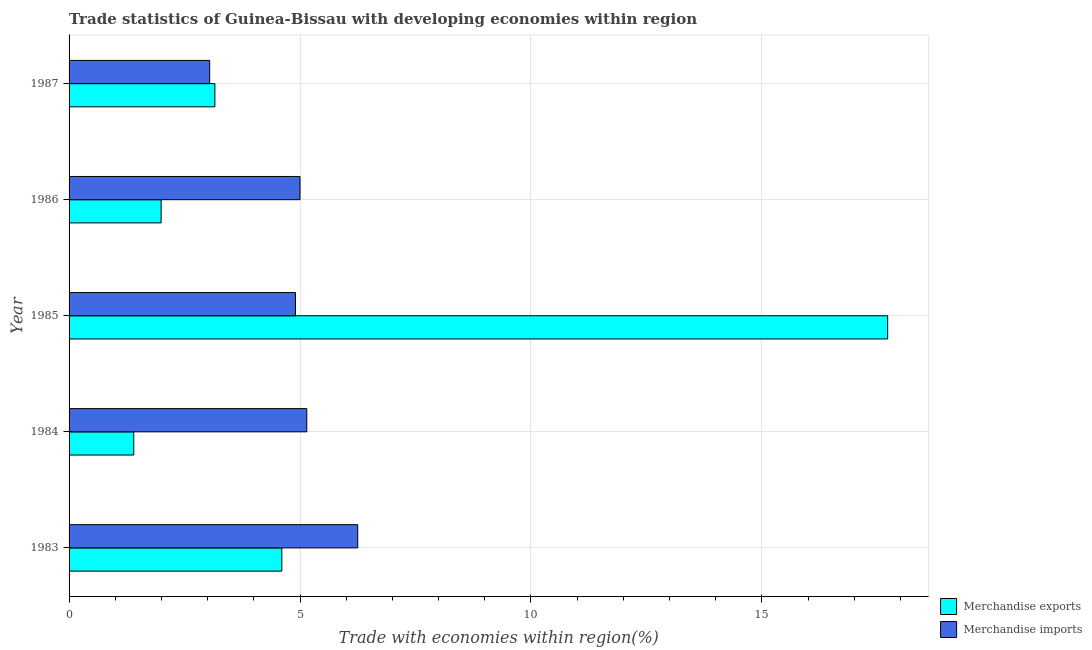How many different coloured bars are there?
Make the answer very short. 2. Are the number of bars on each tick of the Y-axis equal?
Your response must be concise. Yes. How many bars are there on the 3rd tick from the bottom?
Keep it short and to the point. 2. What is the label of the 4th group of bars from the top?
Make the answer very short. 1984. In how many cases, is the number of bars for a given year not equal to the number of legend labels?
Your response must be concise. 0. Across all years, what is the maximum merchandise imports?
Offer a very short reply. 6.25. Across all years, what is the minimum merchandise exports?
Ensure brevity in your answer.  1.4. What is the total merchandise imports in the graph?
Provide a succinct answer. 24.34. What is the difference between the merchandise imports in 1983 and that in 1986?
Your answer should be compact. 1.25. What is the difference between the merchandise exports in 1985 and the merchandise imports in 1986?
Provide a short and direct response. 12.72. What is the average merchandise imports per year?
Give a very brief answer. 4.87. In the year 1986, what is the difference between the merchandise imports and merchandise exports?
Your response must be concise. 3.01. What is the ratio of the merchandise exports in 1986 to that in 1987?
Your response must be concise. 0.63. Is the merchandise imports in 1984 less than that in 1987?
Your answer should be very brief. No. Is the difference between the merchandise exports in 1986 and 1987 greater than the difference between the merchandise imports in 1986 and 1987?
Your response must be concise. No. What is the difference between the highest and the second highest merchandise exports?
Ensure brevity in your answer.  13.12. What is the difference between the highest and the lowest merchandise exports?
Your answer should be compact. 16.32. In how many years, is the merchandise exports greater than the average merchandise exports taken over all years?
Your response must be concise. 1. Is the sum of the merchandise imports in 1983 and 1985 greater than the maximum merchandise exports across all years?
Provide a succinct answer. No. What does the 1st bar from the top in 1986 represents?
Offer a terse response. Merchandise imports. How many bars are there?
Ensure brevity in your answer.  10. What is the difference between two consecutive major ticks on the X-axis?
Give a very brief answer. 5. Are the values on the major ticks of X-axis written in scientific E-notation?
Your answer should be compact. No. Does the graph contain any zero values?
Keep it short and to the point. No. Does the graph contain grids?
Give a very brief answer. Yes. How are the legend labels stacked?
Ensure brevity in your answer.  Vertical. What is the title of the graph?
Keep it short and to the point. Trade statistics of Guinea-Bissau with developing economies within region. Does "Under-five" appear as one of the legend labels in the graph?
Your response must be concise. No. What is the label or title of the X-axis?
Offer a terse response. Trade with economies within region(%). What is the label or title of the Y-axis?
Keep it short and to the point. Year. What is the Trade with economies within region(%) of Merchandise exports in 1983?
Your answer should be very brief. 4.61. What is the Trade with economies within region(%) of Merchandise imports in 1983?
Keep it short and to the point. 6.25. What is the Trade with economies within region(%) in Merchandise exports in 1984?
Make the answer very short. 1.4. What is the Trade with economies within region(%) of Merchandise imports in 1984?
Offer a terse response. 5.15. What is the Trade with economies within region(%) in Merchandise exports in 1985?
Offer a very short reply. 17.72. What is the Trade with economies within region(%) of Merchandise imports in 1985?
Your response must be concise. 4.9. What is the Trade with economies within region(%) in Merchandise exports in 1986?
Give a very brief answer. 1.99. What is the Trade with economies within region(%) in Merchandise exports in 1987?
Your answer should be compact. 3.16. What is the Trade with economies within region(%) in Merchandise imports in 1987?
Ensure brevity in your answer.  3.04. Across all years, what is the maximum Trade with economies within region(%) in Merchandise exports?
Your answer should be compact. 17.72. Across all years, what is the maximum Trade with economies within region(%) of Merchandise imports?
Provide a short and direct response. 6.25. Across all years, what is the minimum Trade with economies within region(%) in Merchandise exports?
Your answer should be very brief. 1.4. Across all years, what is the minimum Trade with economies within region(%) in Merchandise imports?
Ensure brevity in your answer.  3.04. What is the total Trade with economies within region(%) in Merchandise exports in the graph?
Your answer should be compact. 28.88. What is the total Trade with economies within region(%) of Merchandise imports in the graph?
Your response must be concise. 24.34. What is the difference between the Trade with economies within region(%) of Merchandise exports in 1983 and that in 1984?
Keep it short and to the point. 3.21. What is the difference between the Trade with economies within region(%) of Merchandise imports in 1983 and that in 1984?
Provide a short and direct response. 1.1. What is the difference between the Trade with economies within region(%) in Merchandise exports in 1983 and that in 1985?
Your answer should be very brief. -13.12. What is the difference between the Trade with economies within region(%) in Merchandise imports in 1983 and that in 1985?
Make the answer very short. 1.35. What is the difference between the Trade with economies within region(%) in Merchandise exports in 1983 and that in 1986?
Your answer should be compact. 2.61. What is the difference between the Trade with economies within region(%) in Merchandise exports in 1983 and that in 1987?
Make the answer very short. 1.45. What is the difference between the Trade with economies within region(%) of Merchandise imports in 1983 and that in 1987?
Your answer should be very brief. 3.21. What is the difference between the Trade with economies within region(%) in Merchandise exports in 1984 and that in 1985?
Offer a terse response. -16.32. What is the difference between the Trade with economies within region(%) of Merchandise imports in 1984 and that in 1985?
Your answer should be compact. 0.25. What is the difference between the Trade with economies within region(%) in Merchandise exports in 1984 and that in 1986?
Offer a terse response. -0.59. What is the difference between the Trade with economies within region(%) in Merchandise imports in 1984 and that in 1986?
Your response must be concise. 0.15. What is the difference between the Trade with economies within region(%) of Merchandise exports in 1984 and that in 1987?
Your response must be concise. -1.76. What is the difference between the Trade with economies within region(%) in Merchandise imports in 1984 and that in 1987?
Keep it short and to the point. 2.1. What is the difference between the Trade with economies within region(%) of Merchandise exports in 1985 and that in 1986?
Your answer should be compact. 15.73. What is the difference between the Trade with economies within region(%) of Merchandise imports in 1985 and that in 1986?
Make the answer very short. -0.1. What is the difference between the Trade with economies within region(%) of Merchandise exports in 1985 and that in 1987?
Your response must be concise. 14.57. What is the difference between the Trade with economies within region(%) of Merchandise imports in 1985 and that in 1987?
Ensure brevity in your answer.  1.86. What is the difference between the Trade with economies within region(%) in Merchandise exports in 1986 and that in 1987?
Your answer should be compact. -1.16. What is the difference between the Trade with economies within region(%) in Merchandise imports in 1986 and that in 1987?
Offer a terse response. 1.96. What is the difference between the Trade with economies within region(%) of Merchandise exports in 1983 and the Trade with economies within region(%) of Merchandise imports in 1984?
Provide a succinct answer. -0.54. What is the difference between the Trade with economies within region(%) of Merchandise exports in 1983 and the Trade with economies within region(%) of Merchandise imports in 1985?
Your answer should be very brief. -0.3. What is the difference between the Trade with economies within region(%) in Merchandise exports in 1983 and the Trade with economies within region(%) in Merchandise imports in 1986?
Offer a terse response. -0.39. What is the difference between the Trade with economies within region(%) of Merchandise exports in 1983 and the Trade with economies within region(%) of Merchandise imports in 1987?
Provide a short and direct response. 1.56. What is the difference between the Trade with economies within region(%) in Merchandise exports in 1984 and the Trade with economies within region(%) in Merchandise imports in 1985?
Offer a terse response. -3.5. What is the difference between the Trade with economies within region(%) in Merchandise exports in 1984 and the Trade with economies within region(%) in Merchandise imports in 1986?
Offer a terse response. -3.6. What is the difference between the Trade with economies within region(%) of Merchandise exports in 1984 and the Trade with economies within region(%) of Merchandise imports in 1987?
Provide a succinct answer. -1.64. What is the difference between the Trade with economies within region(%) in Merchandise exports in 1985 and the Trade with economies within region(%) in Merchandise imports in 1986?
Your answer should be compact. 12.72. What is the difference between the Trade with economies within region(%) in Merchandise exports in 1985 and the Trade with economies within region(%) in Merchandise imports in 1987?
Give a very brief answer. 14.68. What is the difference between the Trade with economies within region(%) of Merchandise exports in 1986 and the Trade with economies within region(%) of Merchandise imports in 1987?
Ensure brevity in your answer.  -1.05. What is the average Trade with economies within region(%) of Merchandise exports per year?
Your answer should be compact. 5.78. What is the average Trade with economies within region(%) in Merchandise imports per year?
Ensure brevity in your answer.  4.87. In the year 1983, what is the difference between the Trade with economies within region(%) of Merchandise exports and Trade with economies within region(%) of Merchandise imports?
Keep it short and to the point. -1.64. In the year 1984, what is the difference between the Trade with economies within region(%) in Merchandise exports and Trade with economies within region(%) in Merchandise imports?
Your answer should be very brief. -3.75. In the year 1985, what is the difference between the Trade with economies within region(%) in Merchandise exports and Trade with economies within region(%) in Merchandise imports?
Keep it short and to the point. 12.82. In the year 1986, what is the difference between the Trade with economies within region(%) in Merchandise exports and Trade with economies within region(%) in Merchandise imports?
Your answer should be compact. -3.01. In the year 1987, what is the difference between the Trade with economies within region(%) of Merchandise exports and Trade with economies within region(%) of Merchandise imports?
Your response must be concise. 0.11. What is the ratio of the Trade with economies within region(%) in Merchandise exports in 1983 to that in 1984?
Keep it short and to the point. 3.29. What is the ratio of the Trade with economies within region(%) of Merchandise imports in 1983 to that in 1984?
Provide a short and direct response. 1.21. What is the ratio of the Trade with economies within region(%) in Merchandise exports in 1983 to that in 1985?
Your response must be concise. 0.26. What is the ratio of the Trade with economies within region(%) in Merchandise imports in 1983 to that in 1985?
Give a very brief answer. 1.27. What is the ratio of the Trade with economies within region(%) in Merchandise exports in 1983 to that in 1986?
Give a very brief answer. 2.31. What is the ratio of the Trade with economies within region(%) in Merchandise imports in 1983 to that in 1986?
Provide a succinct answer. 1.25. What is the ratio of the Trade with economies within region(%) in Merchandise exports in 1983 to that in 1987?
Offer a terse response. 1.46. What is the ratio of the Trade with economies within region(%) in Merchandise imports in 1983 to that in 1987?
Provide a short and direct response. 2.05. What is the ratio of the Trade with economies within region(%) of Merchandise exports in 1984 to that in 1985?
Make the answer very short. 0.08. What is the ratio of the Trade with economies within region(%) of Merchandise exports in 1984 to that in 1986?
Keep it short and to the point. 0.7. What is the ratio of the Trade with economies within region(%) in Merchandise imports in 1984 to that in 1986?
Provide a succinct answer. 1.03. What is the ratio of the Trade with economies within region(%) in Merchandise exports in 1984 to that in 1987?
Offer a very short reply. 0.44. What is the ratio of the Trade with economies within region(%) in Merchandise imports in 1984 to that in 1987?
Keep it short and to the point. 1.69. What is the ratio of the Trade with economies within region(%) of Merchandise exports in 1985 to that in 1986?
Your response must be concise. 8.89. What is the ratio of the Trade with economies within region(%) in Merchandise imports in 1985 to that in 1986?
Offer a terse response. 0.98. What is the ratio of the Trade with economies within region(%) of Merchandise exports in 1985 to that in 1987?
Provide a succinct answer. 5.61. What is the ratio of the Trade with economies within region(%) in Merchandise imports in 1985 to that in 1987?
Give a very brief answer. 1.61. What is the ratio of the Trade with economies within region(%) of Merchandise exports in 1986 to that in 1987?
Keep it short and to the point. 0.63. What is the ratio of the Trade with economies within region(%) of Merchandise imports in 1986 to that in 1987?
Provide a succinct answer. 1.64. What is the difference between the highest and the second highest Trade with economies within region(%) in Merchandise exports?
Your answer should be very brief. 13.12. What is the difference between the highest and the second highest Trade with economies within region(%) of Merchandise imports?
Your answer should be very brief. 1.1. What is the difference between the highest and the lowest Trade with economies within region(%) in Merchandise exports?
Offer a terse response. 16.32. What is the difference between the highest and the lowest Trade with economies within region(%) in Merchandise imports?
Provide a succinct answer. 3.21. 